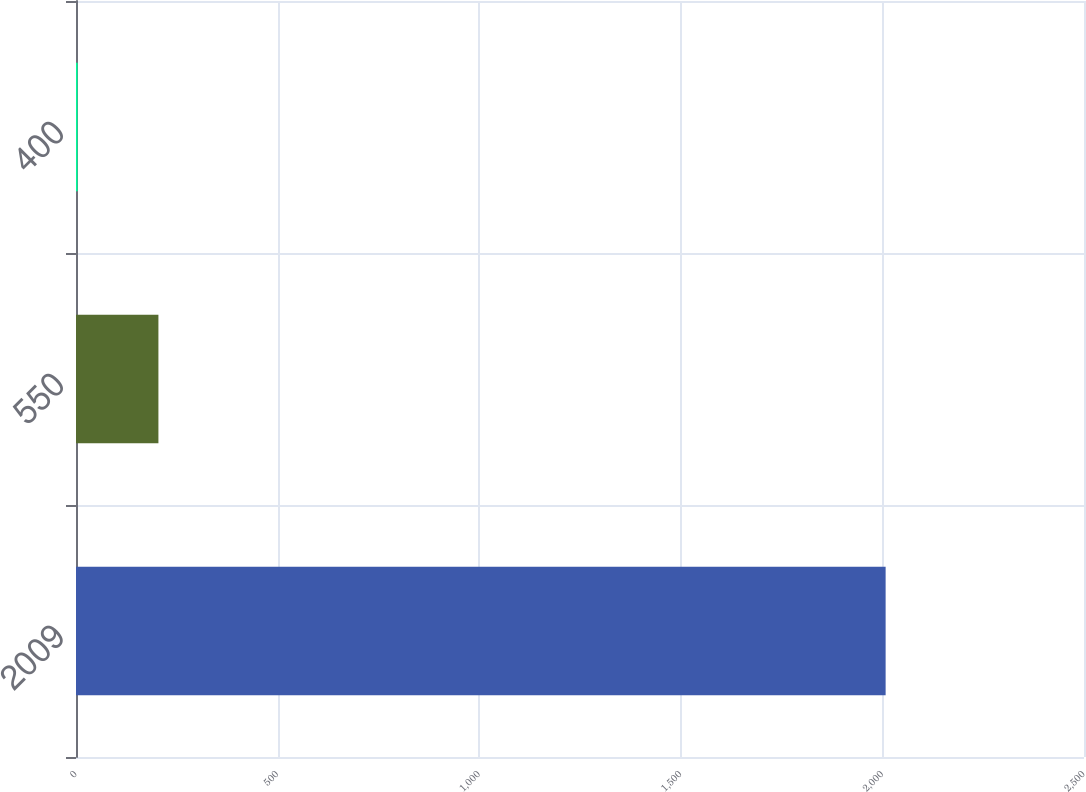Convert chart to OTSL. <chart><loc_0><loc_0><loc_500><loc_500><bar_chart><fcel>2009<fcel>550<fcel>400<nl><fcel>2008<fcel>204.4<fcel>4<nl></chart> 